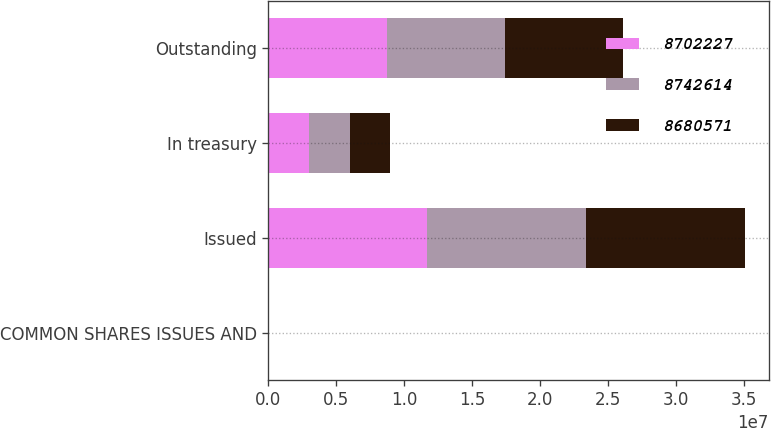<chart> <loc_0><loc_0><loc_500><loc_500><stacked_bar_chart><ecel><fcel>COMMON SHARES ISSUES AND<fcel>Issued<fcel>In treasury<fcel>Outstanding<nl><fcel>8.70223e+06<fcel>2018<fcel>1.16938e+07<fcel>2.99161e+06<fcel>8.70223e+06<nl><fcel>8.74261e+06<fcel>2017<fcel>1.16938e+07<fcel>3.01327e+06<fcel>8.68057e+06<nl><fcel>8.68057e+06<fcel>2016<fcel>1.16938e+07<fcel>2.95123e+06<fcel>8.74261e+06<nl></chart> 